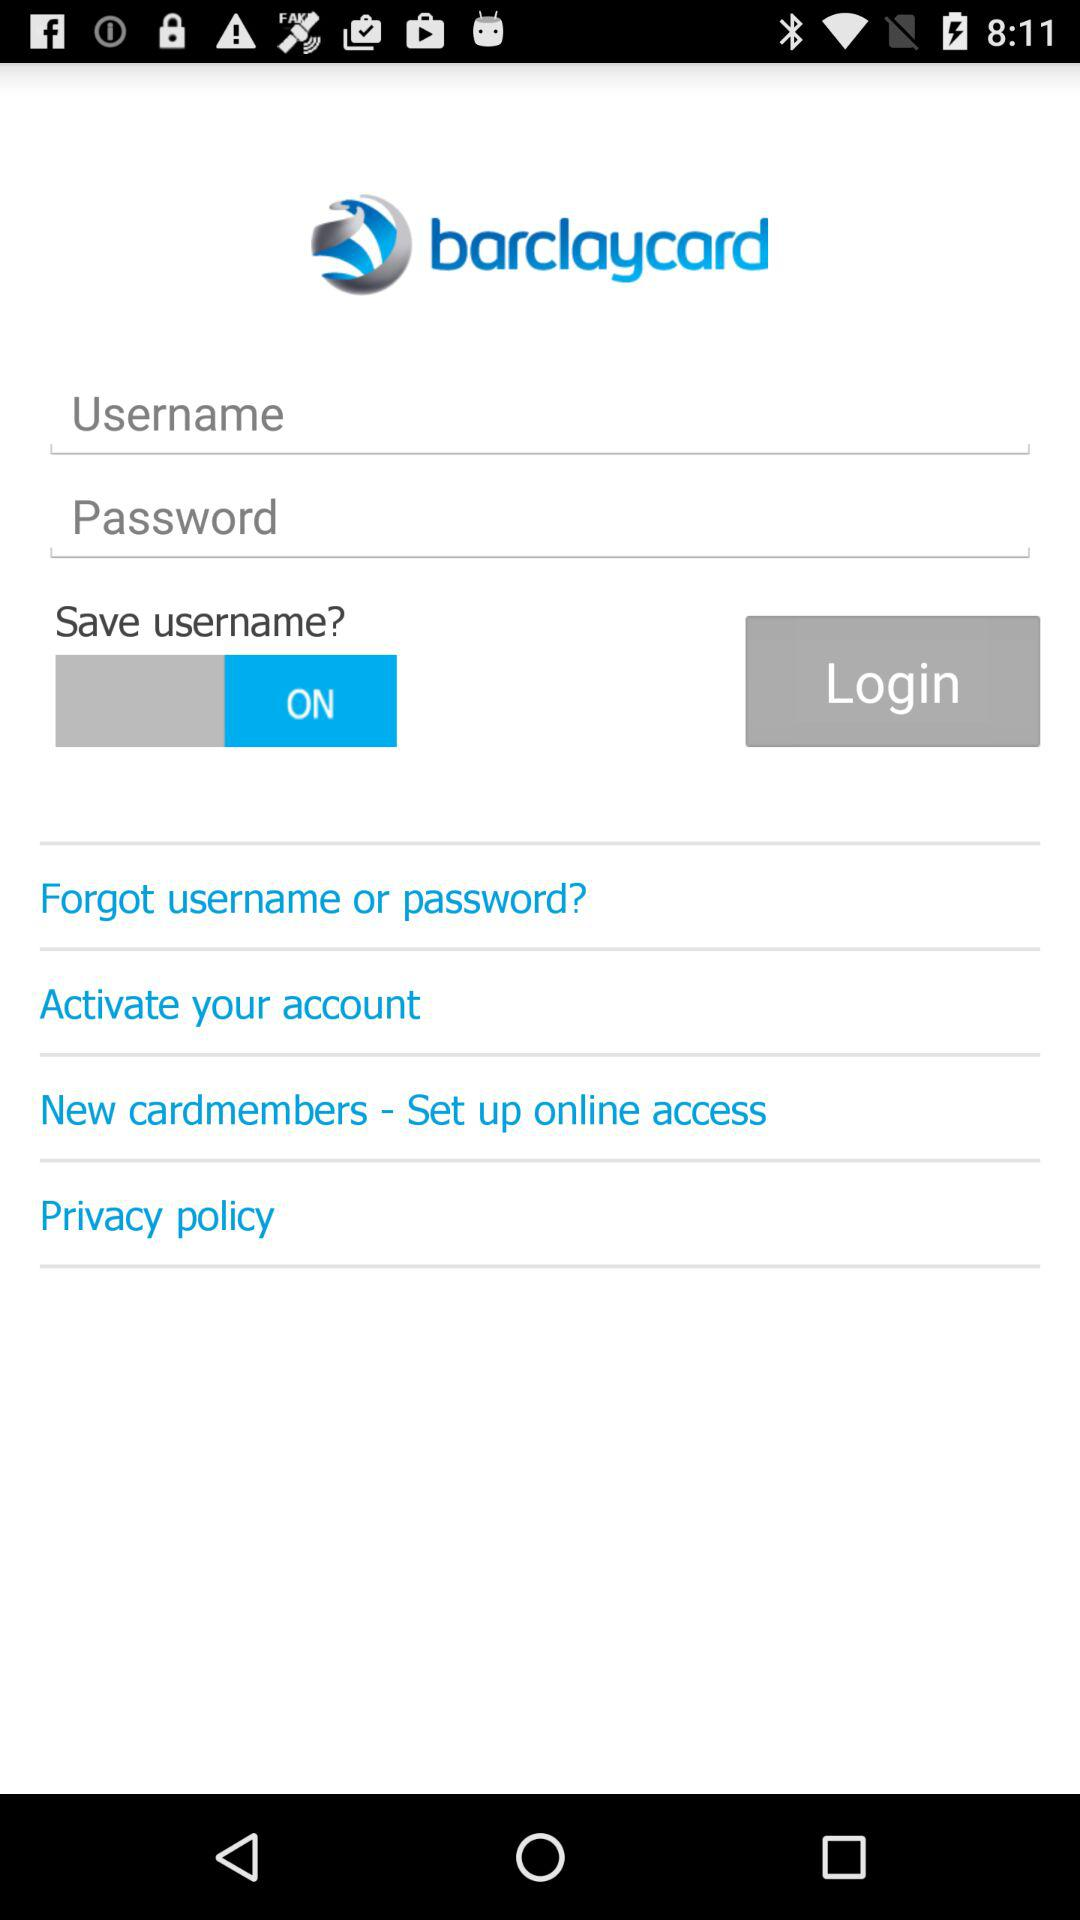How many login fields are there?
Answer the question using a single word or phrase. 2 